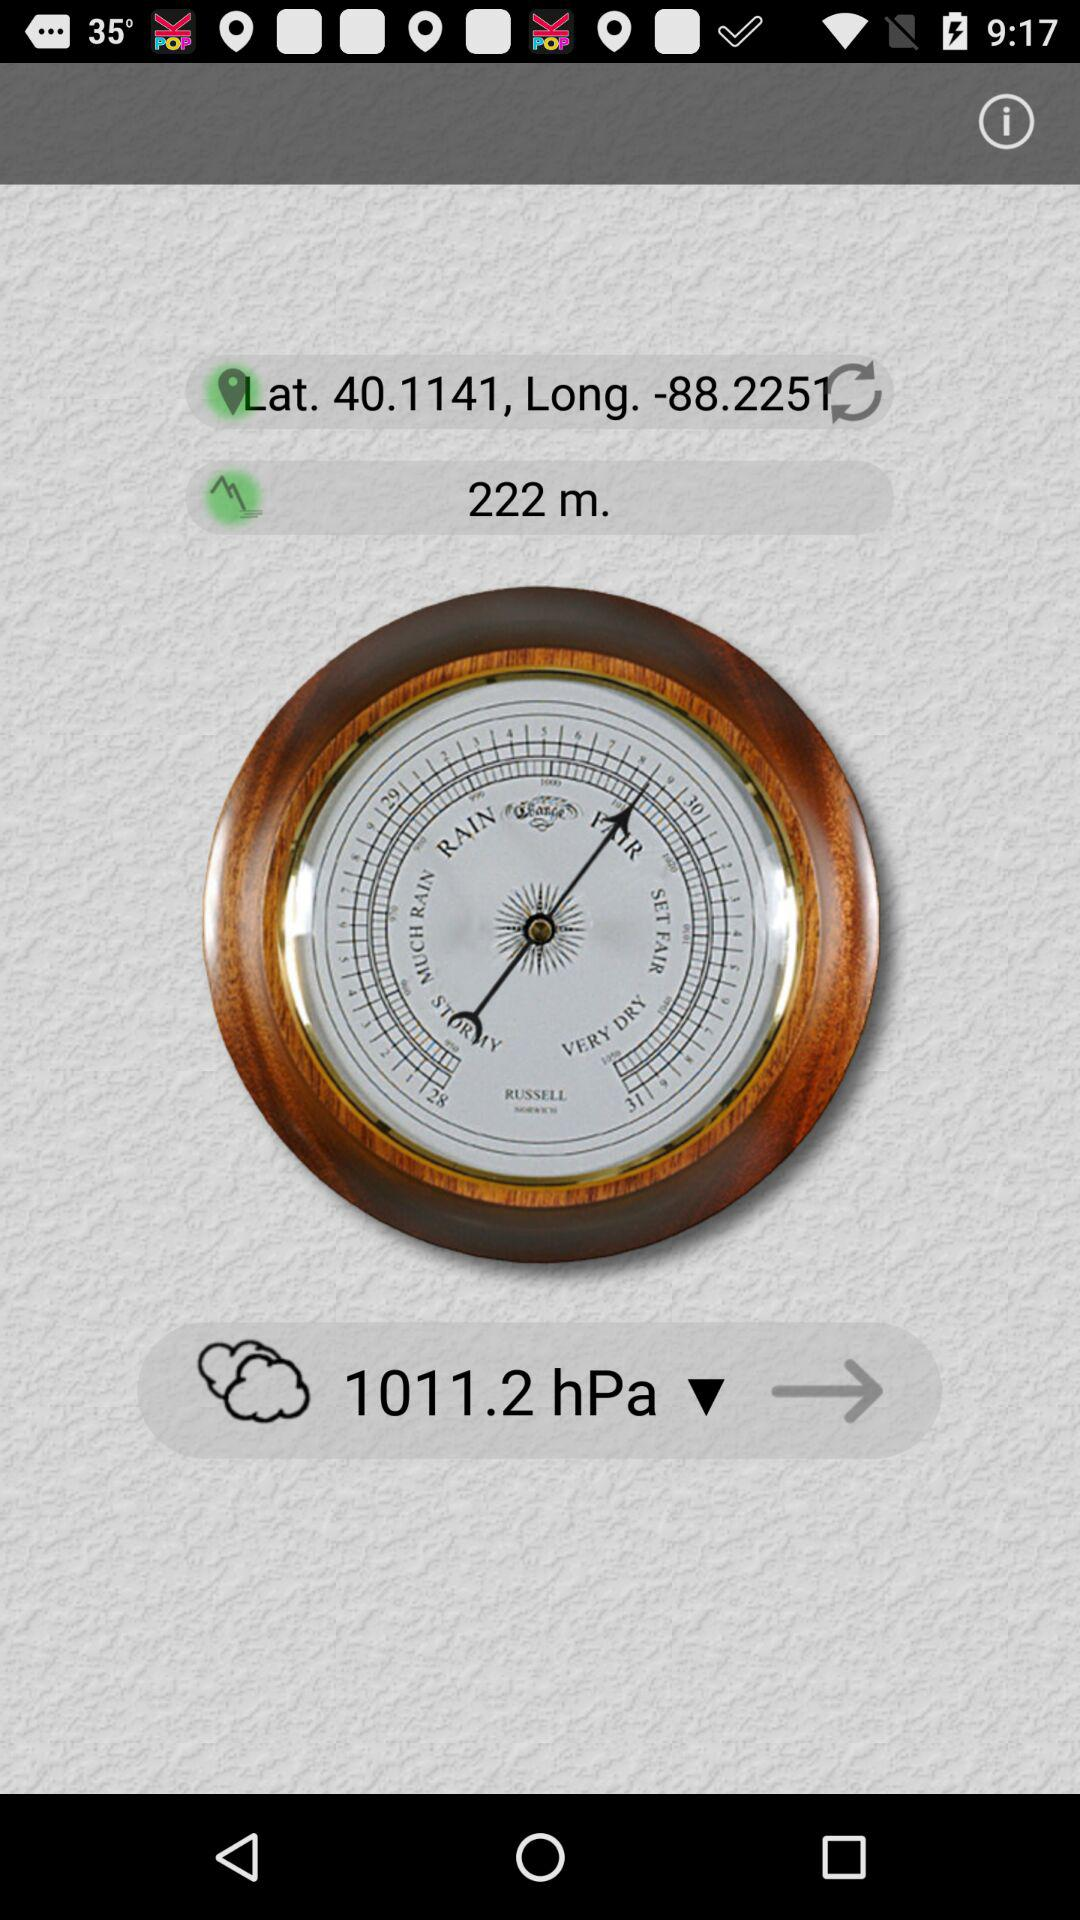What are the mentioned latitude and longitude? The mentioned latitude and longitude are 40.1141 and -88.2251 respectively. 